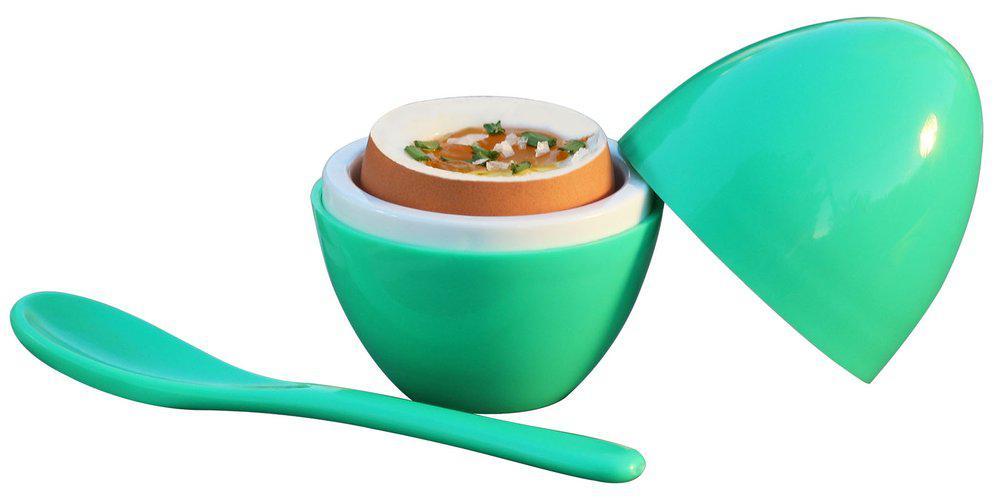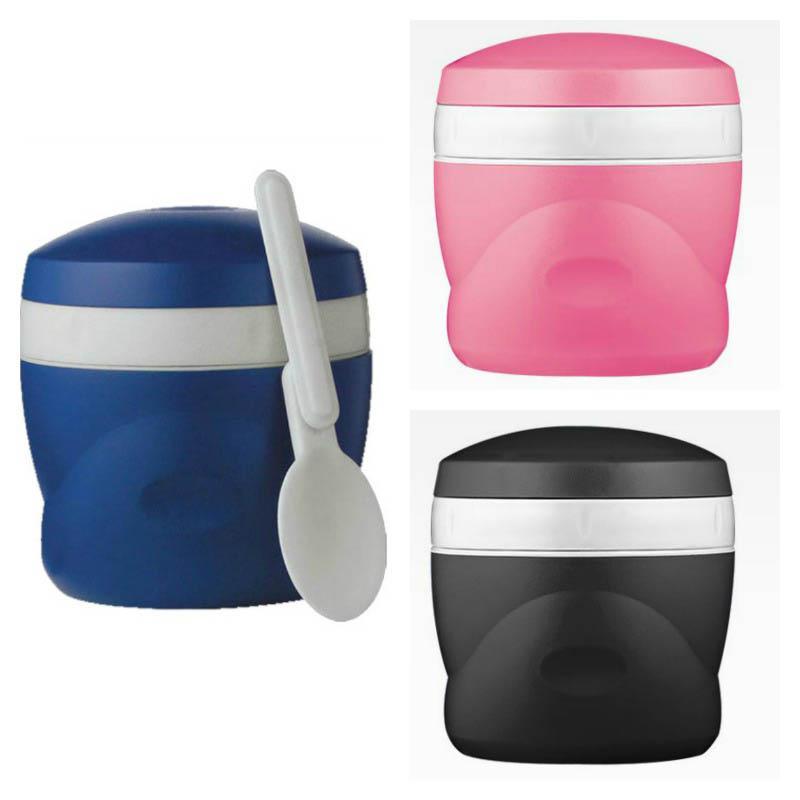The first image is the image on the left, the second image is the image on the right. For the images shown, is this caption "An image includes a royal blue container with a white stripe and white spoon." true? Answer yes or no. Yes. 